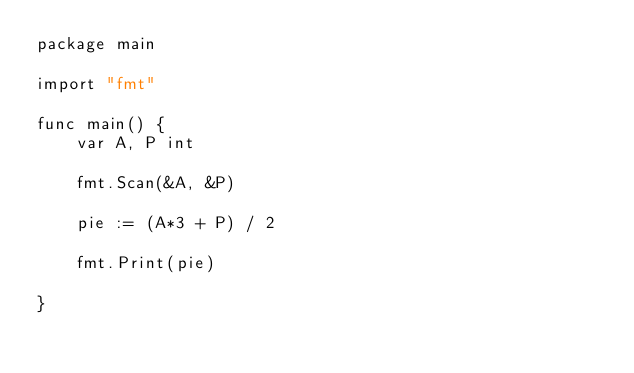Convert code to text. <code><loc_0><loc_0><loc_500><loc_500><_Go_>package main

import "fmt"

func main() {
	var A, P int

	fmt.Scan(&A, &P)

	pie := (A*3 + P) / 2

	fmt.Print(pie)

}
</code> 